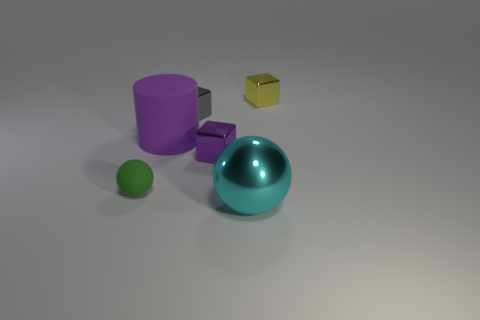Can you tell me the three primary shapes represented in this image? Certainly, the three primary shapes illustrated in this image are the cylinder (the purple object), the sphere (the green and teal objects), and the cube (the purple and yellow objects). 